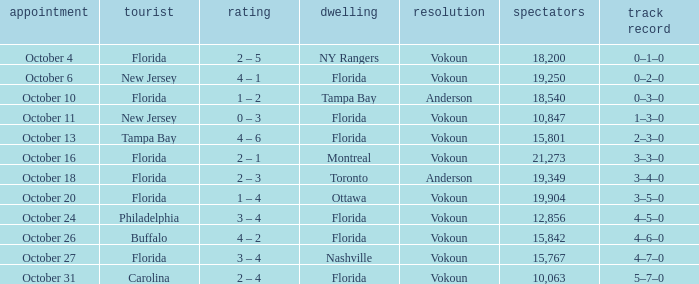What was the score on October 31? 2 – 4. 